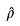Convert formula to latex. <formula><loc_0><loc_0><loc_500><loc_500>\hat { \rho }</formula> 